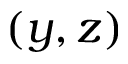Convert formula to latex. <formula><loc_0><loc_0><loc_500><loc_500>( y , z )</formula> 